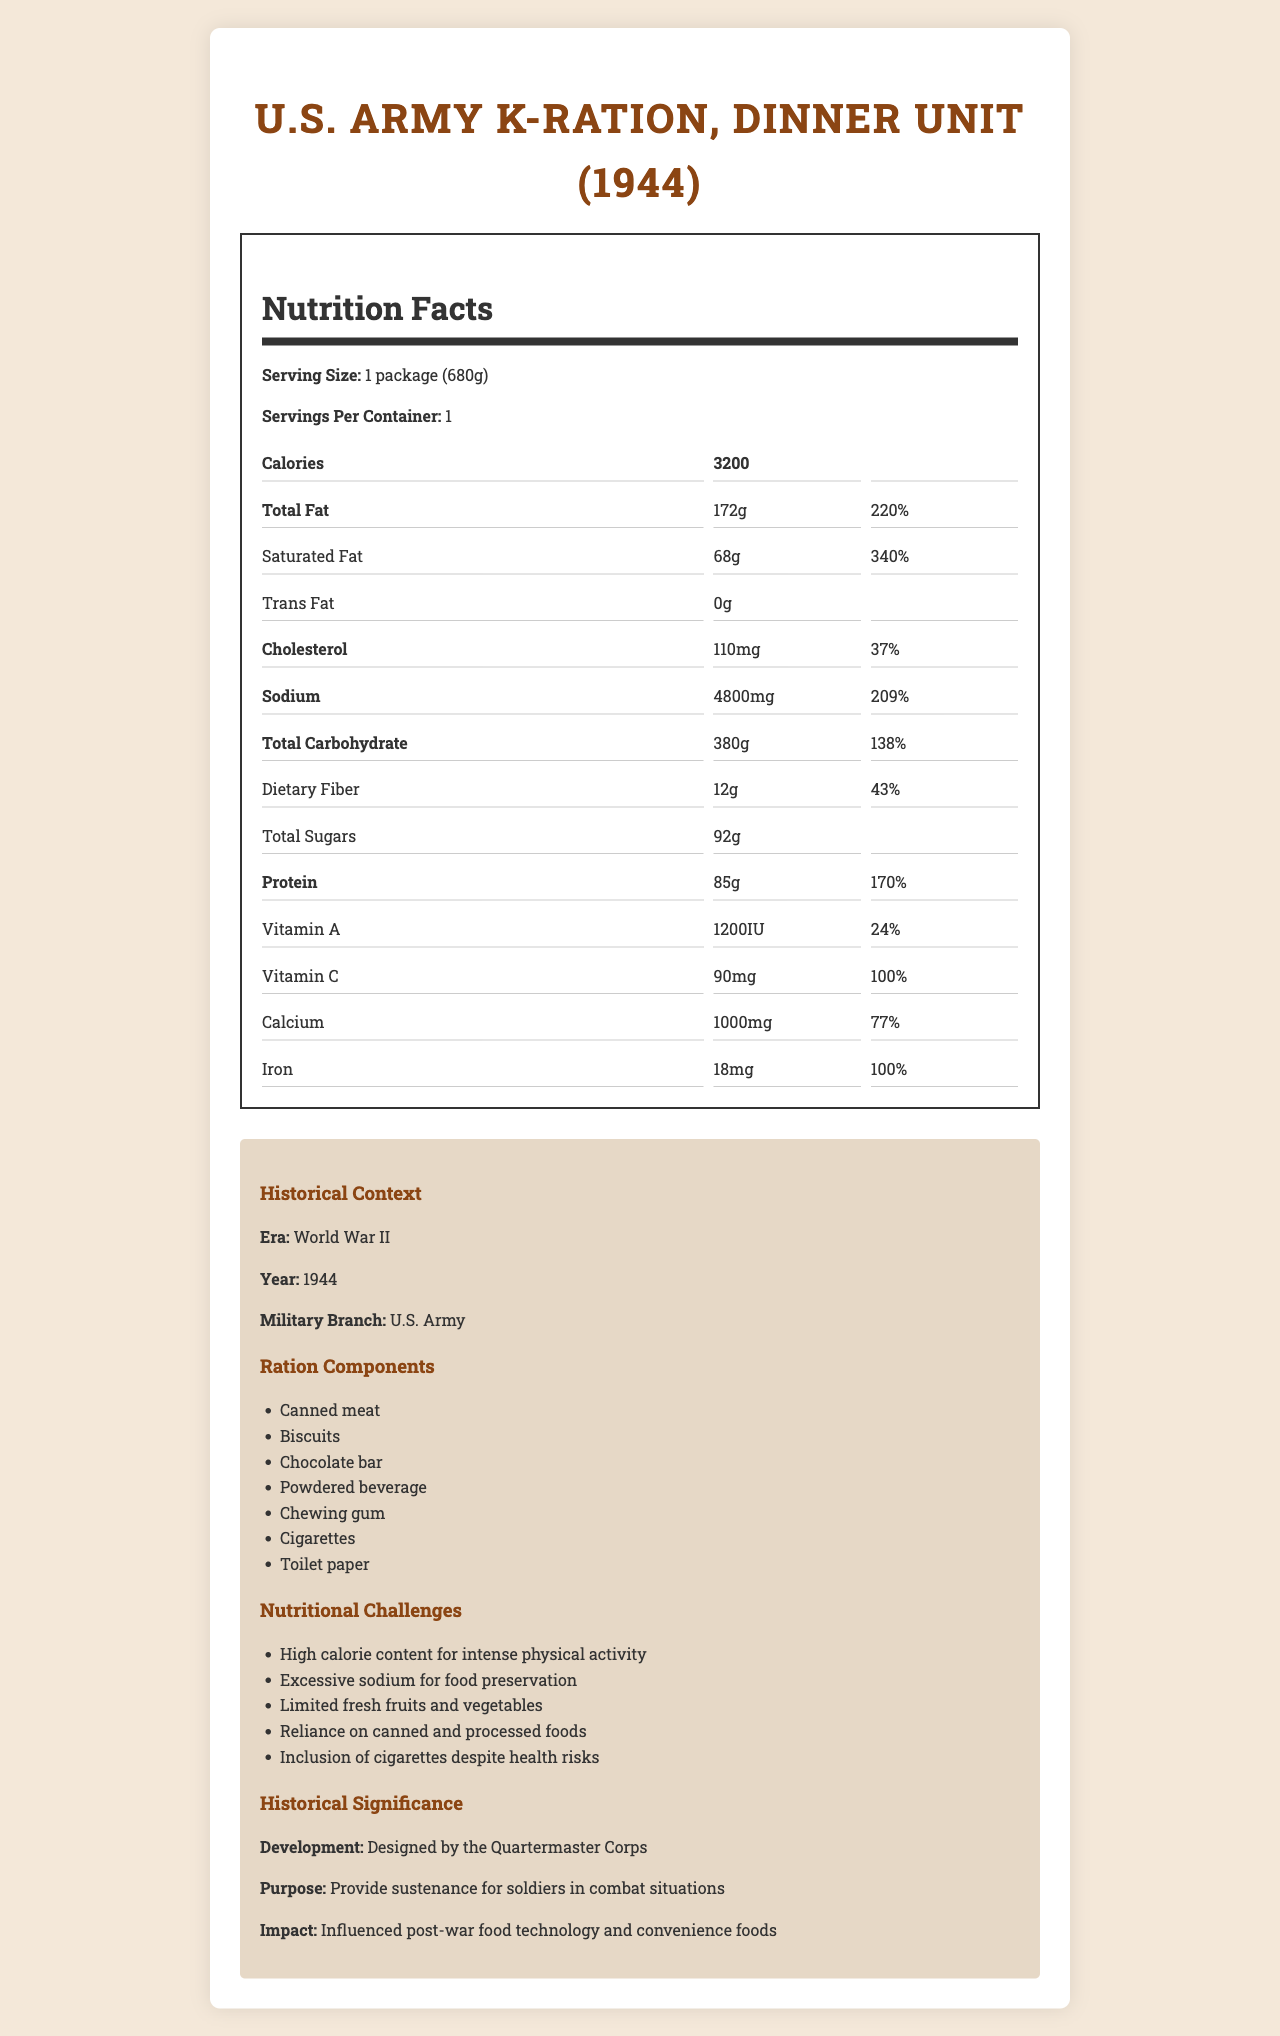What is the serving size of the U.S. Army K-Ration, Dinner Unit (1944)? The serving size is clearly mentioned in the nutrition label as "1 package (680g)."
Answer: 1 package (680g) How many calories are in one serving of this ration pack? The nutrition label states that there are 3200 calories in one serving.
Answer: 3200 What is the purpose of this ration pack according to the document? According to the historical significance section, the purpose is to provide sustenance for soldiers in combat situations.
Answer: Provide sustenance for soldiers in combat situations How many grams of protein does this ration pack contain? The nutrition label shows that there are 85 grams of protein in the ration pack.
Answer: 85g What is the amount of sodium in the ration pack? The nutrition label lists the sodium content as 4800mg.
Answer: 4800mg Which of the following is included in the ration components? A. Fresh fruits B. Canned meat C. Fresh vegetables D. Bread The ration components section includes "Canned meat."
Answer: B What percentage of the daily value for iron does the ration pack provide? A. 24% B. 100% C. 77% D. 43% The nutrition label indicates that the iron content provides 100% of the daily value.
Answer: B True or False: The ration pack contains trans fat. The nutrition label shows that the trans fat amount is 0g.
Answer: False What are some of the nutritional challenges mentioned? The historical context section lists these nutritional challenges specifically.
Answer: High calorie content for intense physical activity, Excessive sodium for food preservation, Limited fresh fruits and vegetables, Reliance on canned and processed foods, Inclusion of cigarettes despite health risks Who developed the U.S. Army K-Ration, Dinner Unit (1944)? The historical significance section states that it was designed by the Quartermaster Corps.
Answer: Quartermaster Corps Summarize the main nutritional challenges faced with the U.S. Army K-Ration, Dinner Unit (1944). The document outlines the main nutritional challenges clearly under the nutritional challenges section.
Answer: The U.S. Army K-Ration faced several nutritional challenges such as providing a high calorie content to support intense physical activity, containing excessive sodium for food preservation, limited fresh fruits and vegetables, reliance on canned and processed foods, and the inclusion of cigarettes despite known health risks. What year was the U.S. Army K-Ration, Dinner Unit (1944) used? The historical context section specifies the year as 1944.
Answer: 1944 Does the document state the exact recipes or preparation methods for the ration components? The document lists the components of the ration pack but does not detail the recipes or preparation methods.
Answer: Not enough information 